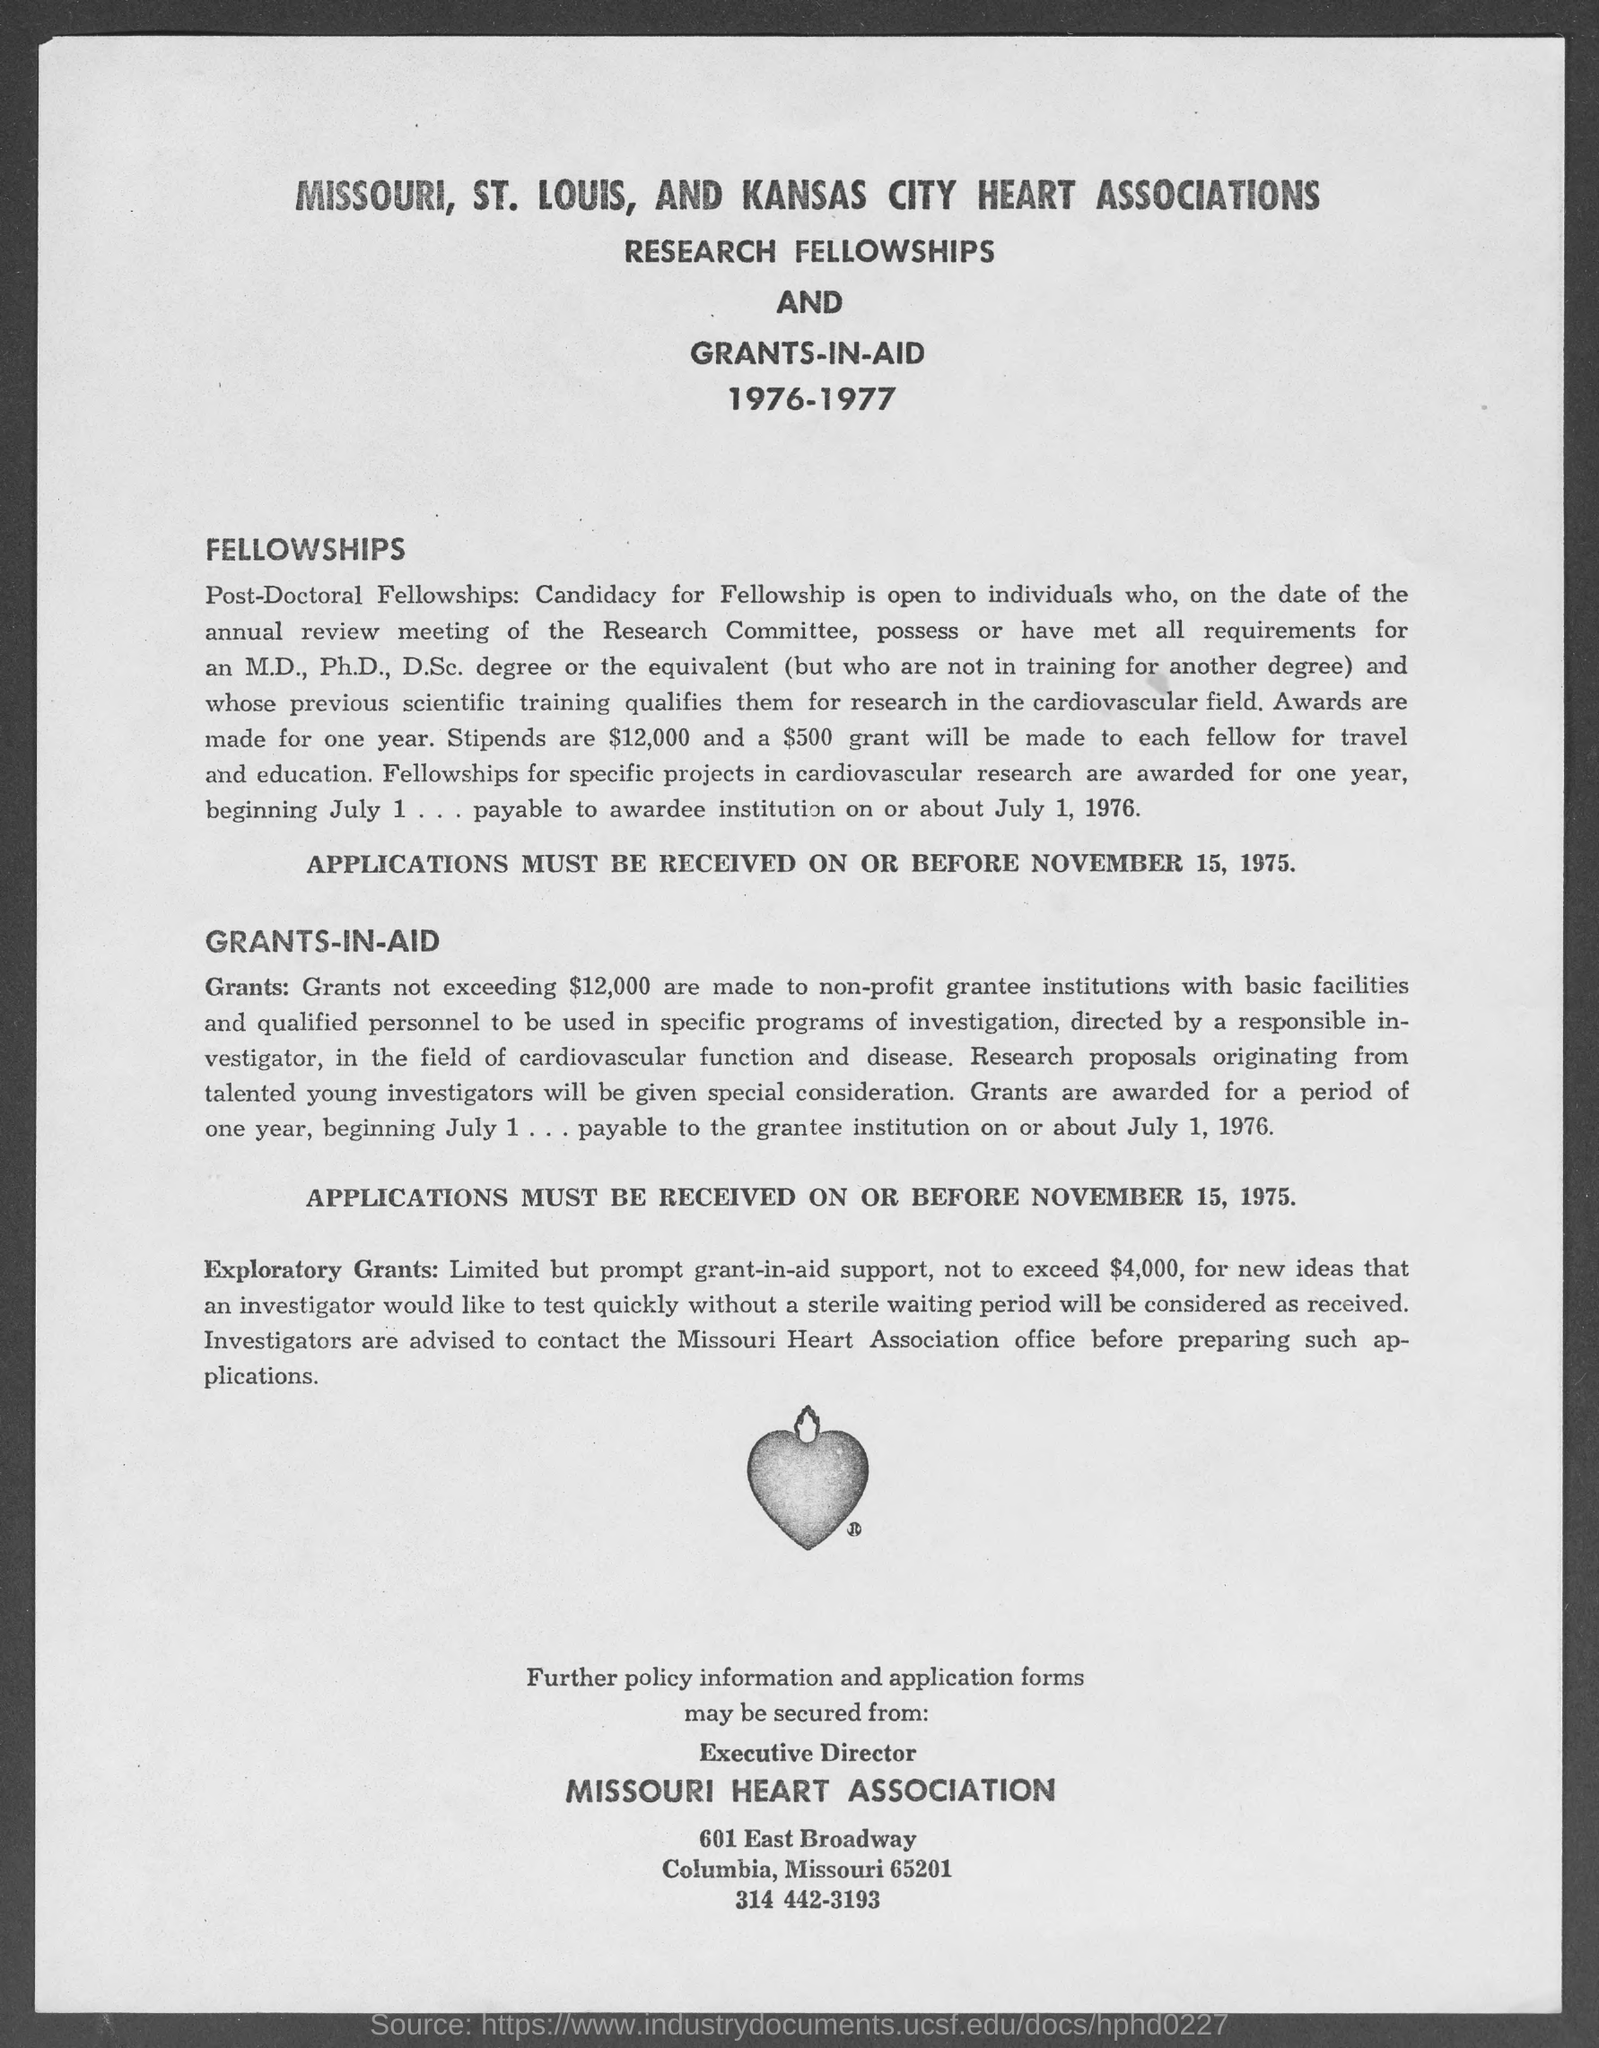Give some essential details in this illustration. Exploratory grants must not exceed $4,000. 